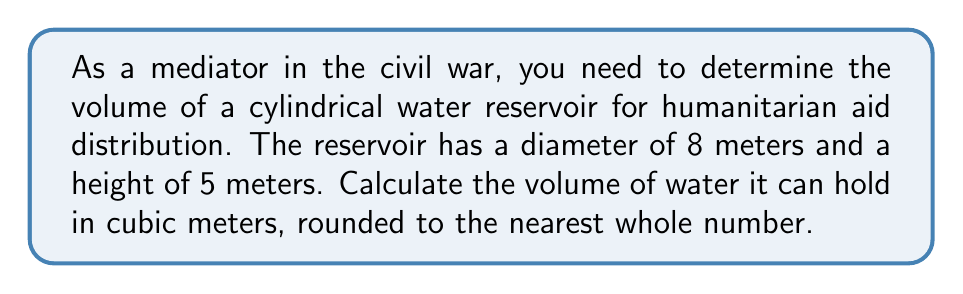Provide a solution to this math problem. To calculate the volume of a cylindrical reservoir, we use the formula:

$$V = \pi r^2 h$$

Where:
$V$ = volume
$r$ = radius
$h$ = height

Steps:
1. Determine the radius:
   Diameter = 8 meters, so radius = 8 ÷ 2 = 4 meters

2. Apply the formula:
   $$V = \pi (4\text{ m})^2 (5\text{ m})$$

3. Calculate:
   $$V = \pi (16\text{ m}^2) (5\text{ m})$$
   $$V = 80\pi \text{ m}^3$$

4. Evaluate and round to the nearest whole number:
   $$V \approx 251.3274 \text{ m}^3 \approx 251 \text{ m}^3$$

Therefore, the cylindrical water reservoir can hold approximately 251 cubic meters of water for humanitarian aid distribution.
Answer: 251 m³ 